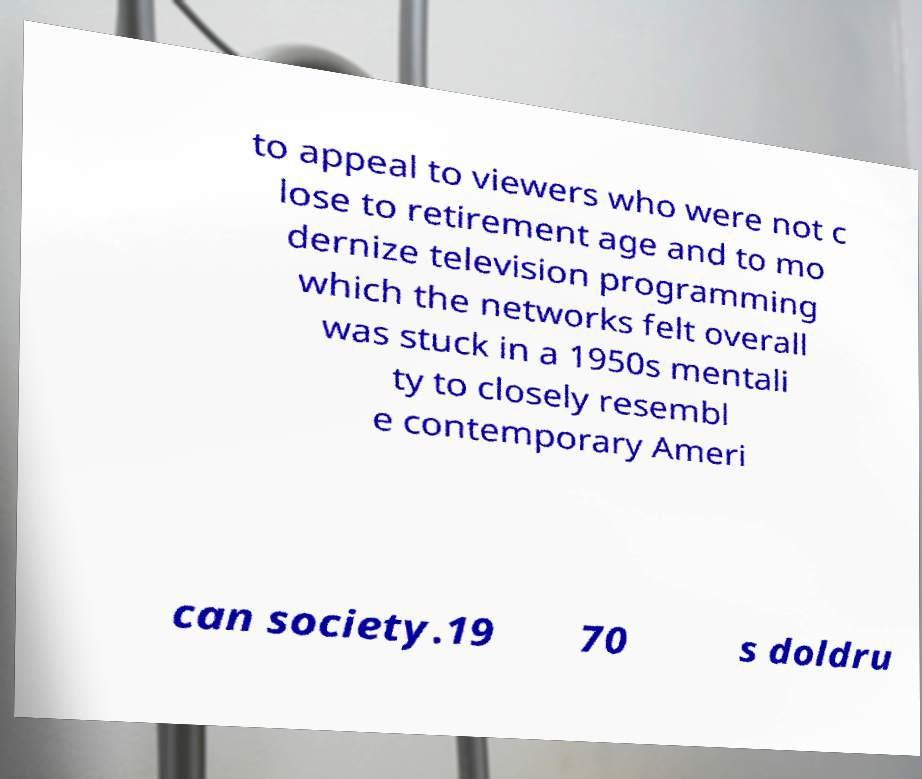There's text embedded in this image that I need extracted. Can you transcribe it verbatim? to appeal to viewers who were not c lose to retirement age and to mo dernize television programming which the networks felt overall was stuck in a 1950s mentali ty to closely resembl e contemporary Ameri can society.19 70 s doldru 